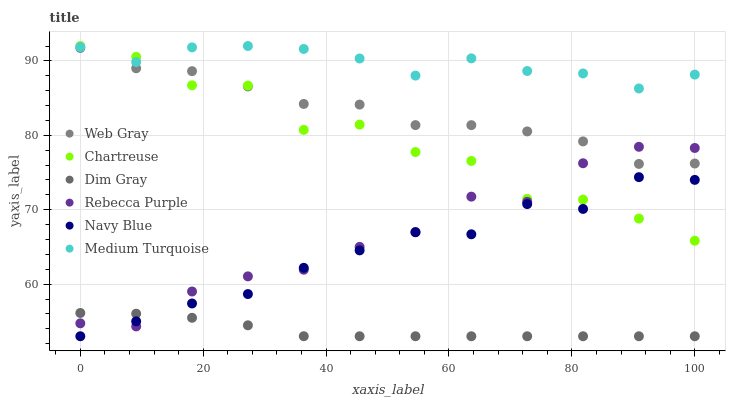Does Dim Gray have the minimum area under the curve?
Answer yes or no. Yes. Does Medium Turquoise have the maximum area under the curve?
Answer yes or no. Yes. Does Navy Blue have the minimum area under the curve?
Answer yes or no. No. Does Navy Blue have the maximum area under the curve?
Answer yes or no. No. Is Dim Gray the smoothest?
Answer yes or no. Yes. Is Chartreuse the roughest?
Answer yes or no. Yes. Is Navy Blue the smoothest?
Answer yes or no. No. Is Navy Blue the roughest?
Answer yes or no. No. Does Navy Blue have the lowest value?
Answer yes or no. Yes. Does Chartreuse have the lowest value?
Answer yes or no. No. Does Medium Turquoise have the highest value?
Answer yes or no. Yes. Does Navy Blue have the highest value?
Answer yes or no. No. Is Dim Gray less than Web Gray?
Answer yes or no. Yes. Is Medium Turquoise greater than Rebecca Purple?
Answer yes or no. Yes. Does Chartreuse intersect Web Gray?
Answer yes or no. Yes. Is Chartreuse less than Web Gray?
Answer yes or no. No. Is Chartreuse greater than Web Gray?
Answer yes or no. No. Does Dim Gray intersect Web Gray?
Answer yes or no. No. 